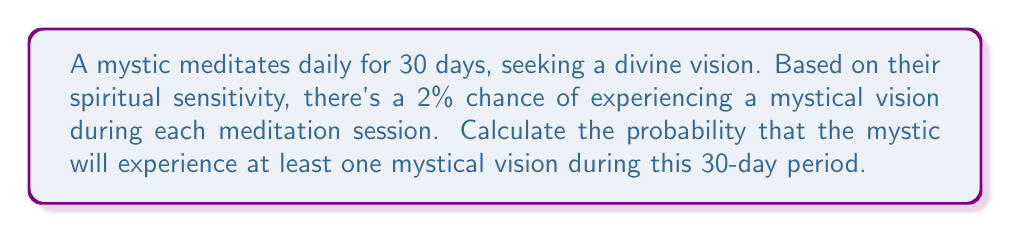Help me with this question. To solve this problem, we'll use the complement method:

1) First, let's calculate the probability of not having a mystical vision in a single meditation session:
   $P(\text{no vision}) = 1 - P(\text{vision}) = 1 - 0.02 = 0.98$

2) For the mystic to not have any visions in 30 days, they must not have a vision every single day. Since each day is independent, we multiply these probabilities:
   $P(\text{no visions in 30 days}) = 0.98^{30}$

3) Now, the probability of having at least one vision is the complement of having no visions:
   $P(\text{at least one vision}) = 1 - P(\text{no visions in 30 days})$

4) Let's calculate this:
   $$\begin{align}
   P(\text{at least one vision}) &= 1 - 0.98^{30} \\
   &= 1 - 0.5455 \\
   &= 0.4545
   \end{align}$$

5) Converting to a percentage:
   $0.4545 \times 100\% = 45.45\%$
Answer: The probability that the mystic will experience at least one mystical vision during the 30-day period is approximately 45.45%. 